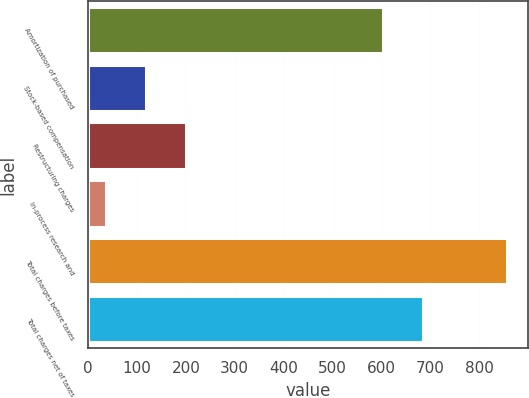Convert chart. <chart><loc_0><loc_0><loc_500><loc_500><bar_chart><fcel>Amortization of purchased<fcel>Stock-based compensation<fcel>Restructuring charges<fcel>In-process research and<fcel>Total charges before taxes<fcel>Total charges net of taxes<nl><fcel>603<fcel>118.9<fcel>200.8<fcel>37<fcel>856<fcel>684.9<nl></chart> 